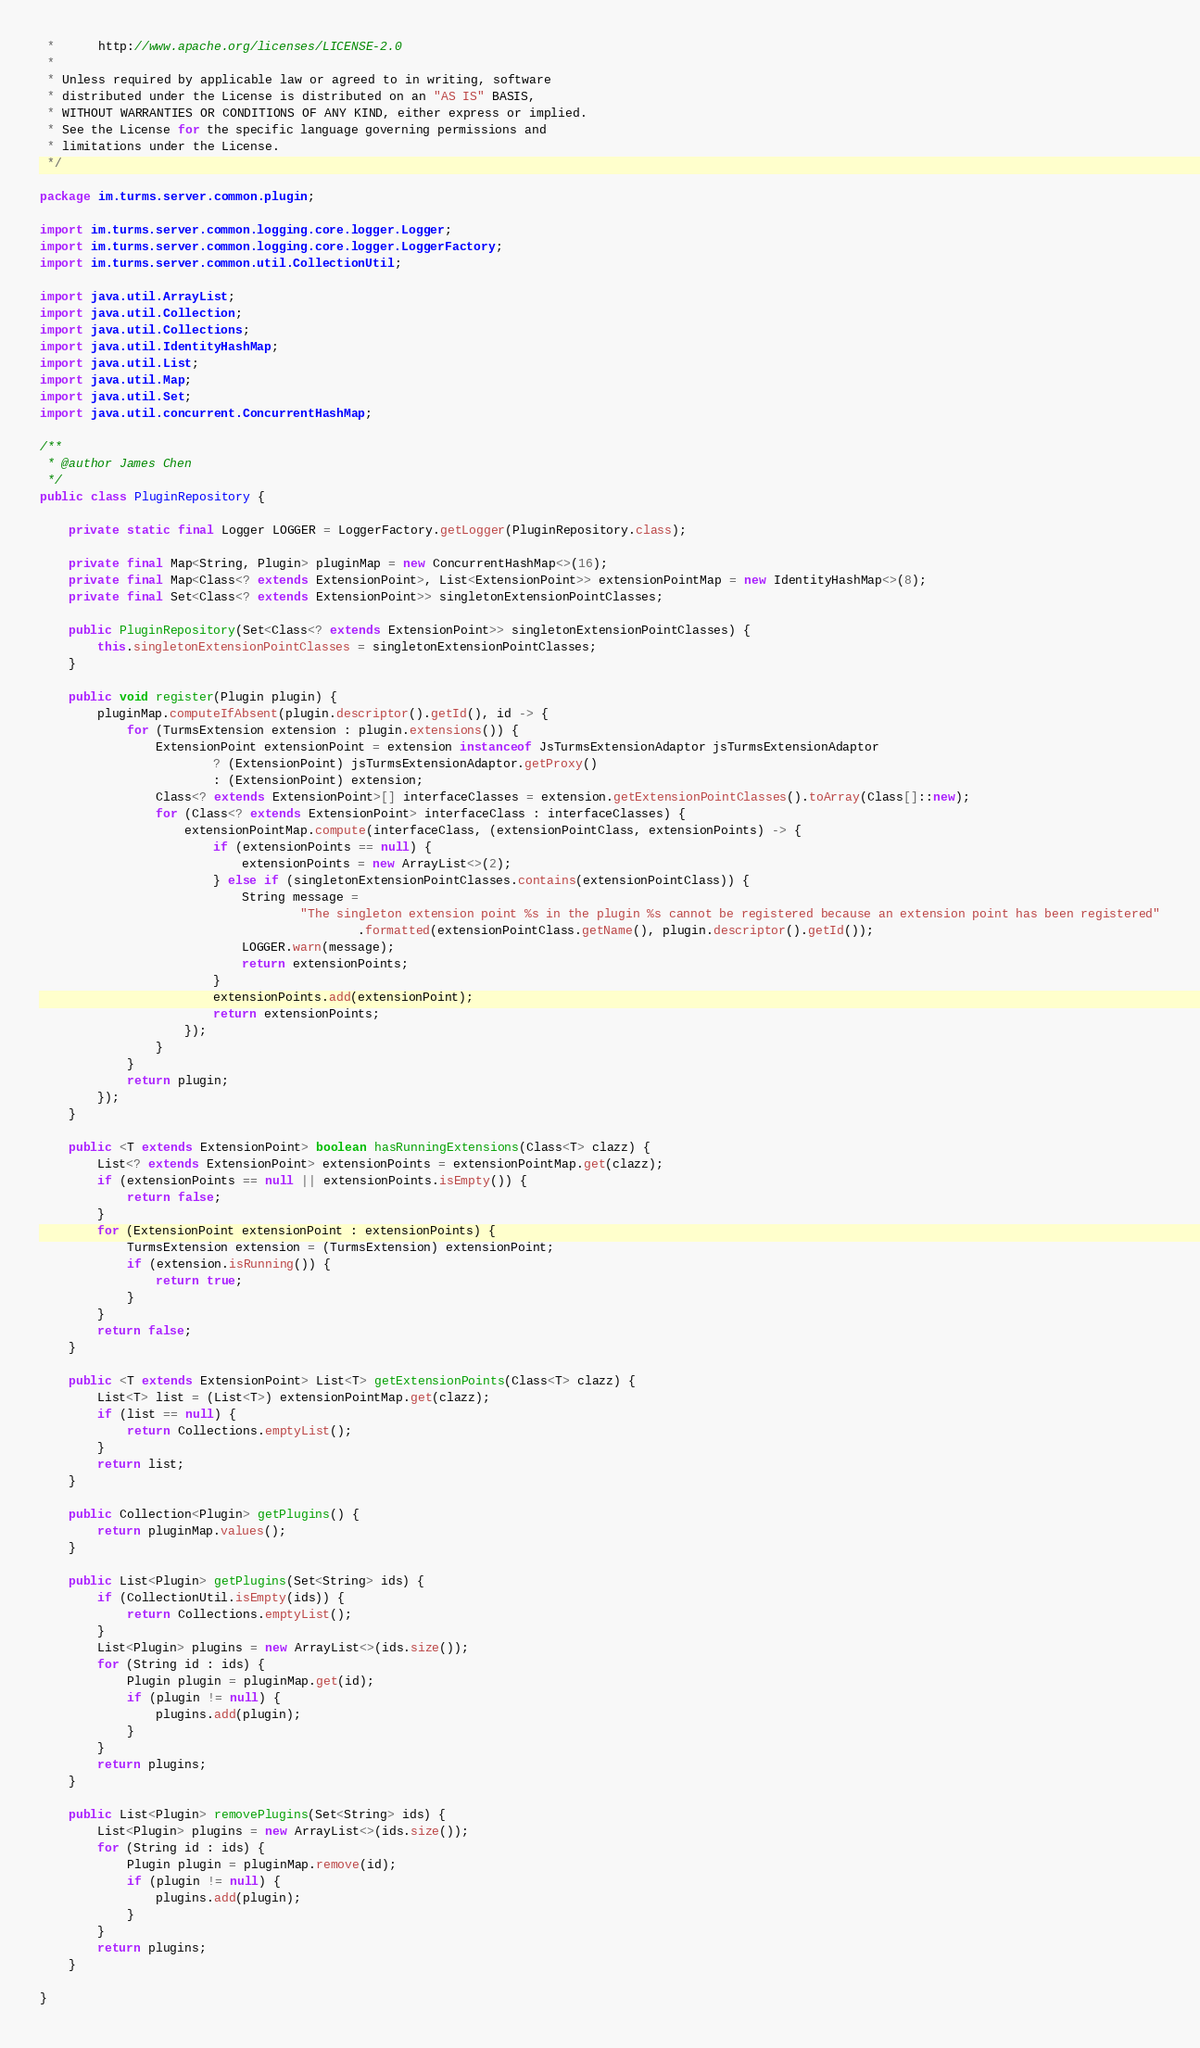<code> <loc_0><loc_0><loc_500><loc_500><_Java_> *      http://www.apache.org/licenses/LICENSE-2.0
 *
 * Unless required by applicable law or agreed to in writing, software
 * distributed under the License is distributed on an "AS IS" BASIS,
 * WITHOUT WARRANTIES OR CONDITIONS OF ANY KIND, either express or implied.
 * See the License for the specific language governing permissions and
 * limitations under the License.
 */

package im.turms.server.common.plugin;

import im.turms.server.common.logging.core.logger.Logger;
import im.turms.server.common.logging.core.logger.LoggerFactory;
import im.turms.server.common.util.CollectionUtil;

import java.util.ArrayList;
import java.util.Collection;
import java.util.Collections;
import java.util.IdentityHashMap;
import java.util.List;
import java.util.Map;
import java.util.Set;
import java.util.concurrent.ConcurrentHashMap;

/**
 * @author James Chen
 */
public class PluginRepository {

    private static final Logger LOGGER = LoggerFactory.getLogger(PluginRepository.class);

    private final Map<String, Plugin> pluginMap = new ConcurrentHashMap<>(16);
    private final Map<Class<? extends ExtensionPoint>, List<ExtensionPoint>> extensionPointMap = new IdentityHashMap<>(8);
    private final Set<Class<? extends ExtensionPoint>> singletonExtensionPointClasses;

    public PluginRepository(Set<Class<? extends ExtensionPoint>> singletonExtensionPointClasses) {
        this.singletonExtensionPointClasses = singletonExtensionPointClasses;
    }

    public void register(Plugin plugin) {
        pluginMap.computeIfAbsent(plugin.descriptor().getId(), id -> {
            for (TurmsExtension extension : plugin.extensions()) {
                ExtensionPoint extensionPoint = extension instanceof JsTurmsExtensionAdaptor jsTurmsExtensionAdaptor
                        ? (ExtensionPoint) jsTurmsExtensionAdaptor.getProxy()
                        : (ExtensionPoint) extension;
                Class<? extends ExtensionPoint>[] interfaceClasses = extension.getExtensionPointClasses().toArray(Class[]::new);
                for (Class<? extends ExtensionPoint> interfaceClass : interfaceClasses) {
                    extensionPointMap.compute(interfaceClass, (extensionPointClass, extensionPoints) -> {
                        if (extensionPoints == null) {
                            extensionPoints = new ArrayList<>(2);
                        } else if (singletonExtensionPointClasses.contains(extensionPointClass)) {
                            String message =
                                    "The singleton extension point %s in the plugin %s cannot be registered because an extension point has been registered"
                                            .formatted(extensionPointClass.getName(), plugin.descriptor().getId());
                            LOGGER.warn(message);
                            return extensionPoints;
                        }
                        extensionPoints.add(extensionPoint);
                        return extensionPoints;
                    });
                }
            }
            return plugin;
        });
    }

    public <T extends ExtensionPoint> boolean hasRunningExtensions(Class<T> clazz) {
        List<? extends ExtensionPoint> extensionPoints = extensionPointMap.get(clazz);
        if (extensionPoints == null || extensionPoints.isEmpty()) {
            return false;
        }
        for (ExtensionPoint extensionPoint : extensionPoints) {
            TurmsExtension extension = (TurmsExtension) extensionPoint;
            if (extension.isRunning()) {
                return true;
            }
        }
        return false;
    }

    public <T extends ExtensionPoint> List<T> getExtensionPoints(Class<T> clazz) {
        List<T> list = (List<T>) extensionPointMap.get(clazz);
        if (list == null) {
            return Collections.emptyList();
        }
        return list;
    }

    public Collection<Plugin> getPlugins() {
        return pluginMap.values();
    }

    public List<Plugin> getPlugins(Set<String> ids) {
        if (CollectionUtil.isEmpty(ids)) {
            return Collections.emptyList();
        }
        List<Plugin> plugins = new ArrayList<>(ids.size());
        for (String id : ids) {
            Plugin plugin = pluginMap.get(id);
            if (plugin != null) {
                plugins.add(plugin);
            }
        }
        return plugins;
    }

    public List<Plugin> removePlugins(Set<String> ids) {
        List<Plugin> plugins = new ArrayList<>(ids.size());
        for (String id : ids) {
            Plugin plugin = pluginMap.remove(id);
            if (plugin != null) {
                plugins.add(plugin);
            }
        }
        return plugins;
    }

}
</code> 